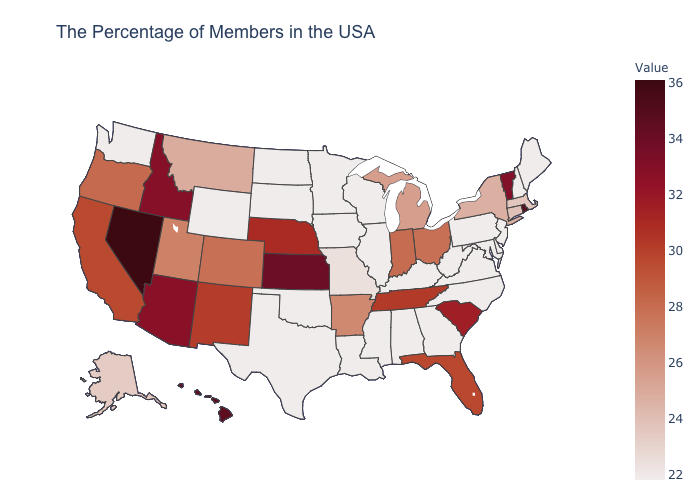Which states have the lowest value in the MidWest?
Quick response, please. Wisconsin, Illinois, Minnesota, Iowa, South Dakota, North Dakota. Among the states that border Maine , which have the highest value?
Concise answer only. New Hampshire. Does the map have missing data?
Write a very short answer. No. Does the map have missing data?
Keep it brief. No. Among the states that border South Dakota , which have the highest value?
Answer briefly. Nebraska. Which states have the lowest value in the USA?
Concise answer only. Maine, New Hampshire, New Jersey, Delaware, Maryland, Pennsylvania, Virginia, North Carolina, West Virginia, Georgia, Kentucky, Alabama, Wisconsin, Illinois, Mississippi, Louisiana, Minnesota, Iowa, Oklahoma, Texas, South Dakota, North Dakota, Wyoming, Washington. Which states have the highest value in the USA?
Answer briefly. Nevada. 